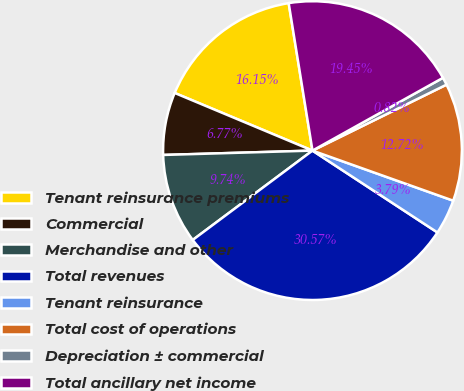Convert chart. <chart><loc_0><loc_0><loc_500><loc_500><pie_chart><fcel>Tenant reinsurance premiums<fcel>Commercial<fcel>Merchandise and other<fcel>Total revenues<fcel>Tenant reinsurance<fcel>Total cost of operations<fcel>Depreciation ± commercial<fcel>Total ancillary net income<nl><fcel>16.15%<fcel>6.77%<fcel>9.74%<fcel>30.57%<fcel>3.79%<fcel>12.72%<fcel>0.82%<fcel>19.45%<nl></chart> 